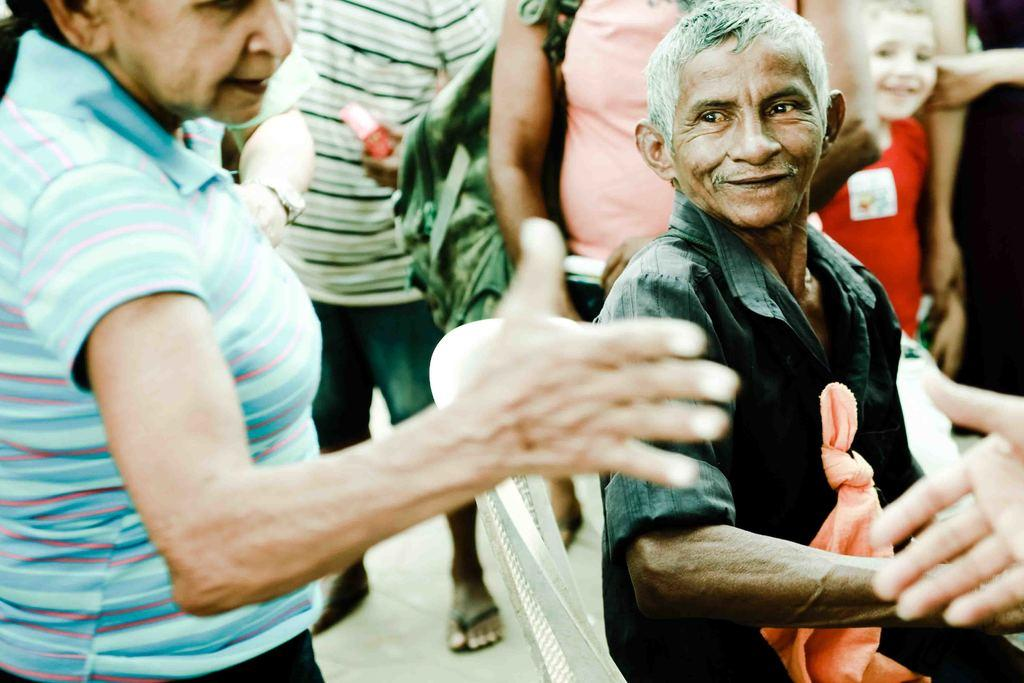What is the main subject of the image? The main subject of the image is a crowd. Where is the crowd located in the image? The crowd is standing on the road. Can you describe the time of day when the image was taken? The image is taken during the day. What type of winter clothing can be seen on the monkey in the image? There is no monkey present in the image, and therefore no winter clothing can be observed. 